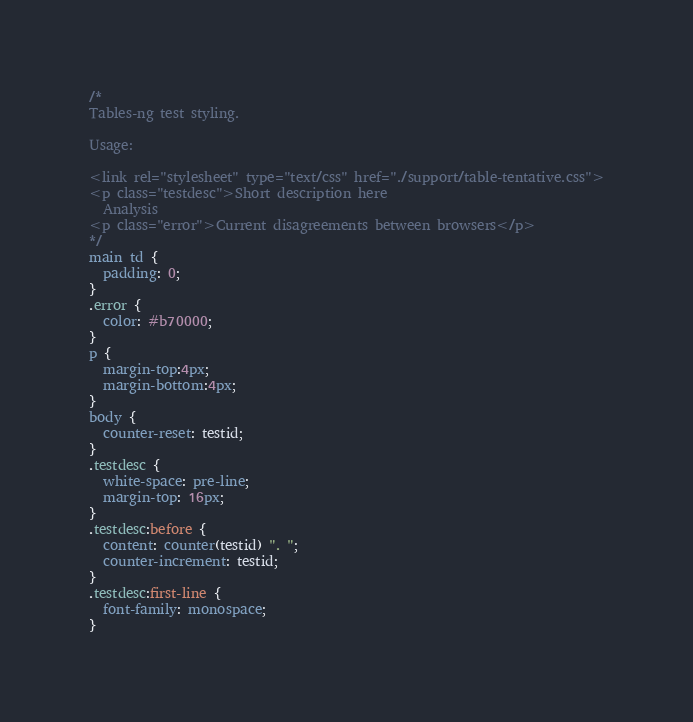Convert code to text. <code><loc_0><loc_0><loc_500><loc_500><_CSS_>/*
Tables-ng test styling.

Usage:

<link rel="stylesheet" type="text/css" href="./support/table-tentative.css">
<p class="testdesc">Short description here
  Analysis
<p class="error">Current disagreements between browsers</p>
*/
main td {
  padding: 0;
}
.error {
  color: #b70000;
}
p {
  margin-top:4px;
  margin-bottom:4px;
}
body {
  counter-reset: testid;
}
.testdesc {
  white-space: pre-line;
  margin-top: 16px;
}
.testdesc:before {
  content: counter(testid) ". ";
  counter-increment: testid;
}
.testdesc:first-line {
  font-family: monospace;
}
</code> 